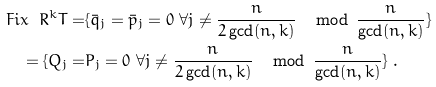<formula> <loc_0><loc_0><loc_500><loc_500>F i x \ R ^ { k } T = & \{ \bar { q } _ { j } = \bar { p } _ { j } = 0 \ \forall j \neq \frac { n } { 2 \gcd ( n , k ) } \, \mod \, \frac { n } { \gcd ( n , k ) } \} \\ = \{ Q _ { j } = & P _ { j } = 0 \ \forall j \neq \frac { n } { 2 \gcd ( n , k ) } \, \mod \, \frac { n } { \gcd ( n , k ) } \} \ .</formula> 